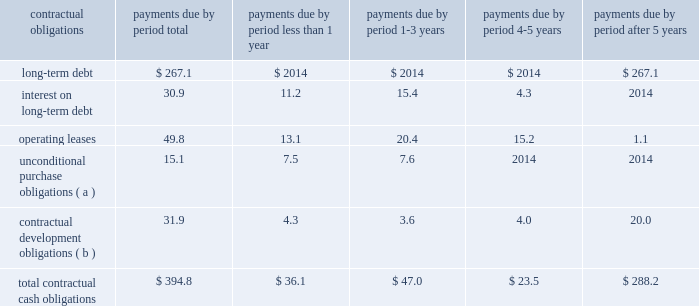) increased net cash flows from receivables from improved days sales outstanding offsetting increased sales levels ; partially offset by reduced cash flows from increases in inventories to build new product lines and support increased sales levels .
Cash provided by operating activities in 2003 decreased $ 8.4 million from 2002 due primarily to : ) reduced cash inflows from accounts receivable securitization ; and ) reduced cash inflows from increases in inventories partially offset by : ) higher earnings in 2003 before non-cash charges and credits ; ) decreased net cash outflows from accounts and other receivables ; and ) decreased net cash outflows from accounts payable and accrued expenses .
Net cash used in investing activities in 2004 consisted primarily of the acquisition of pvt and the purchase of ev3 2019s technology of $ 137.7 million , and capital expenditures of $ 42.5 million .
Net cash used in investing activities in 2003 consisted primarily of the acquisition of jomed , whitland and embol-x , inc .
Of $ 33.2 million , and capital expenditures of $ 37.9 million .
Net cash used in financing activities in 2004 consisted primarily of purchases of treasury stock of $ 59.1 million , partially offset by proceeds from stock plans of $ 30.5 million and net proceeds from issuance of long-term debt of $ 7.1 million .
Cash used in financing activities in 2003 consisted primarily of purchases of treasury stock of $ 49.4 million and net payments on debt of $ 4.0 million , partially offset by proceeds from stock plans of $ 36.6 million .
A summary of all of the company 2019s contractual obligations and commercial commitments as of december 31 , 2004 were as follows ( in millions ) : .
Less than after contractual obligations total 1 year 1-3 years 4-5 years 5 years long-term debt *************************** $ 267.1 $ 2014 $ 2014 $ 2014 $ 267.1 interest on long-term debt ****************** 30.9 11.2 15.4 4.3 2014 operating leases*************************** 49.8 13.1 20.4 15.2 1.1 unconditional purchase obligations ( a ) ********* 15.1 7.5 7.6 2014 2014 contractual development obligations ( b ) ******** 31.9 4.3 3.6 4.0 20.0 total contractual cash obligations************* $ 394.8 $ 36.1 $ 47.0 $ 23.5 $ 288.2 ( a ) unconditional purchase obligations consist primarily of minimum purchase commitments of inventory .
( b ) contractual development obligations consist primarily of cash that edwards lifesciences is obligated to pay to unconsolidated affiliates upon their achievement of product development milestones .
Critical accounting policies and estimates the company 2019s results of operations and financial position are determined based upon the application of the company 2019s accounting policies , as discussed in the notes to the consolidated financial statements .
Certain of the company 2019s accounting policies represent a selection among acceptable alternatives under generally accepted .
What percent of total contractual cash obligations is due to long-term debt? 
Computations: (267.1 / 394.8)
Answer: 0.67655. 